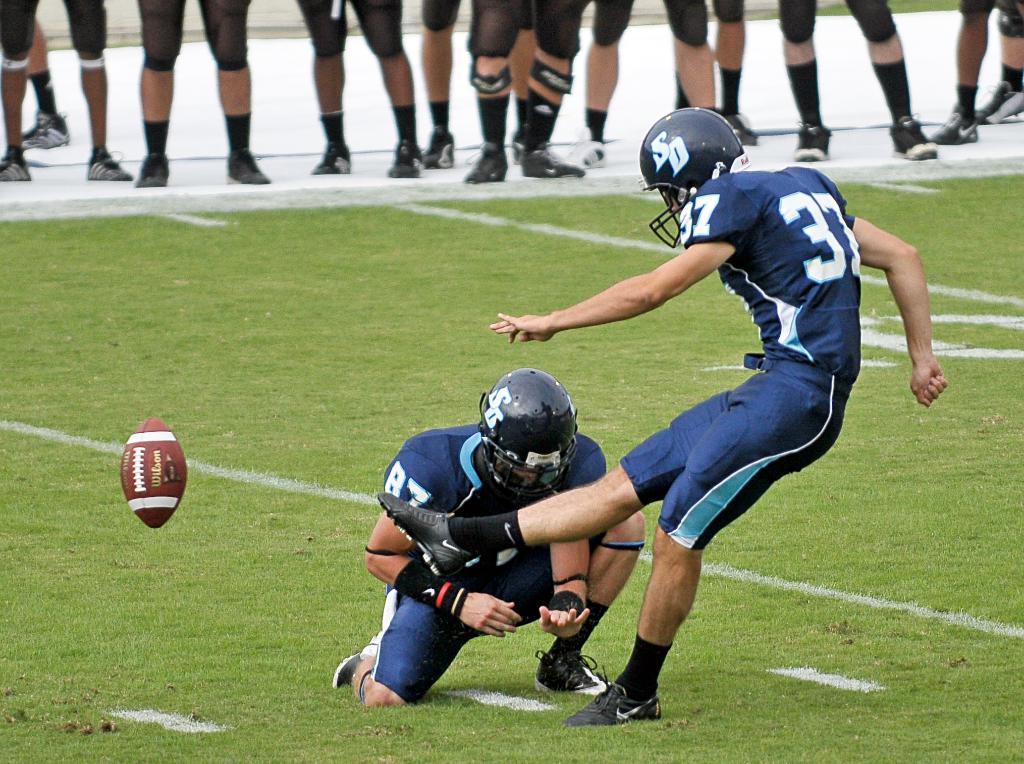Please provide a concise description of this image. In this image we can see group of persons standing on the ground. One person is wearing a blue dress and helmet. To the left side of the image we can see a ball. 